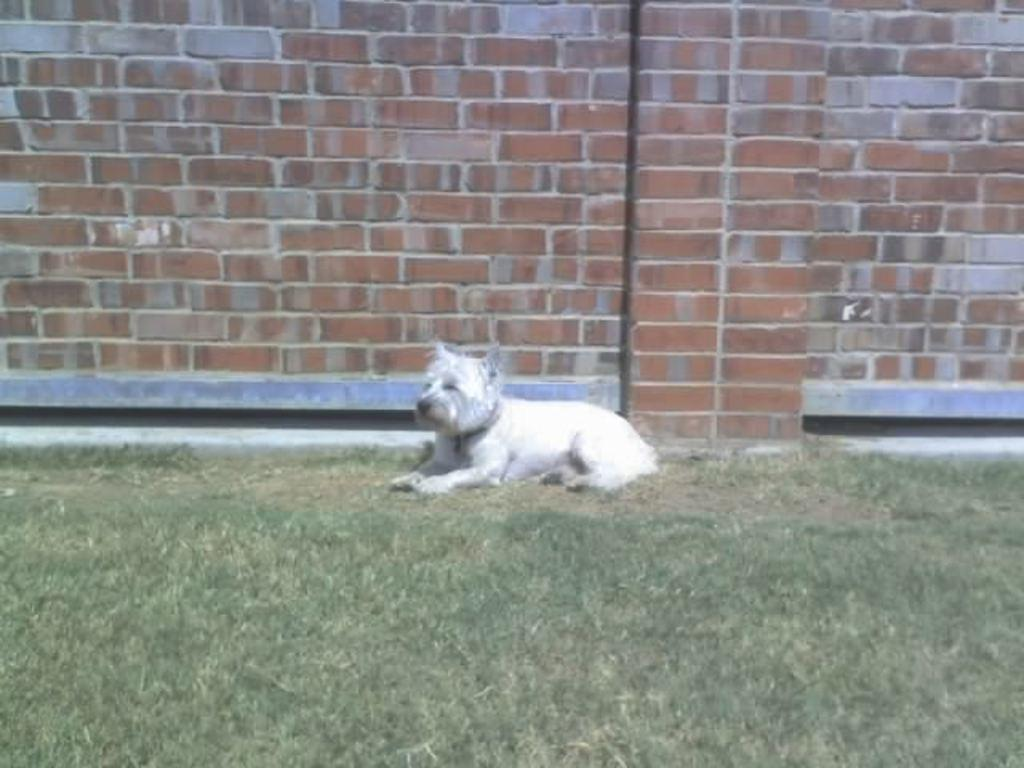What type of animal is in the image? There is a white dog in the image. Where is the dog located? The dog is on the grass. What can be seen in the background of the image? There is a brick wall in the background of the image. What type of van is parked next to the dog in the image? There is no van present in the image; it only features a white dog on the grass with a brick wall in the background. 